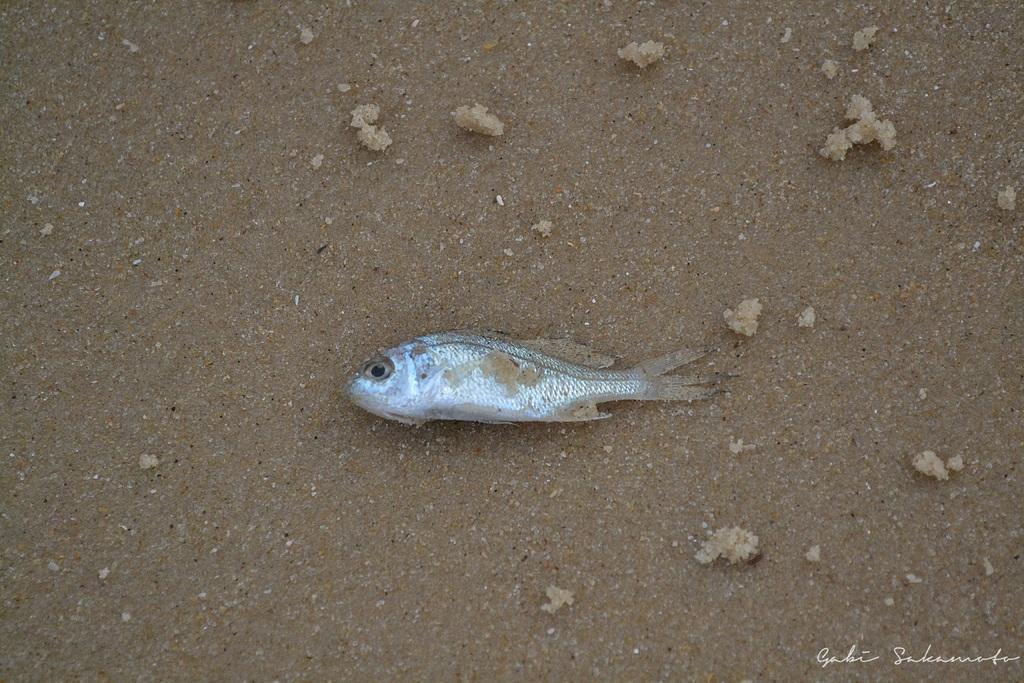What type of surface is visible in the image in the image? There is a wet sand surface in the image. What can be seen on the wet sand surface? There is a fish in the image. What color is the fish? The fish is silver in color. What type of coil is used to catch the fish in the image? There is no coil present in the image; the fish is simply lying on the wet sand surface. 